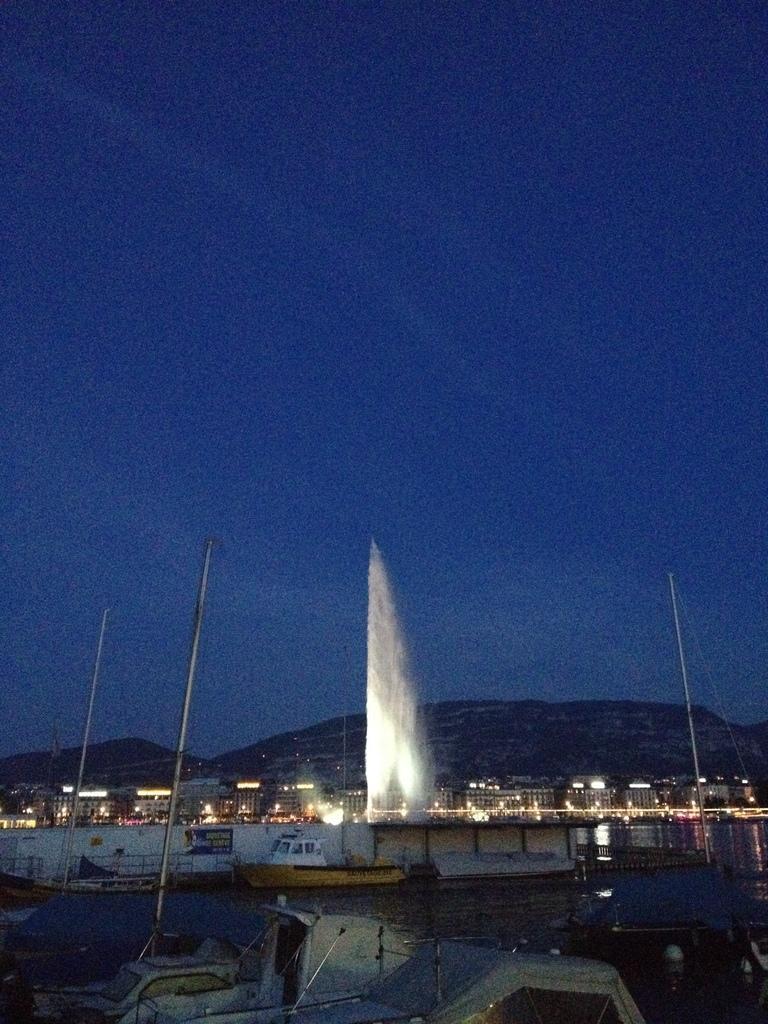Can you describe this image briefly? In this image we can see boats on the water, a bridge, few buildings with lights, mountains and the sky. 